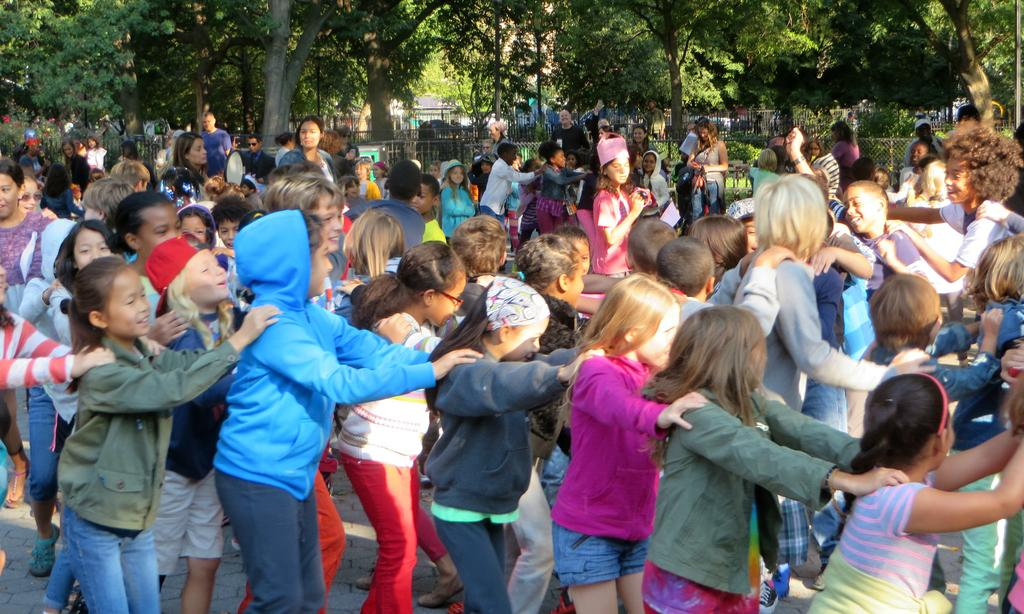What are the children in the image doing? The children are playing in the image. Where are the children playing? The children are playing on the road. What can be seen in the background of the image? There is a fence, plants, and trees in the background of the image. How many uncles are present in the image? There are no uncles present in the image; it features children playing on the road. 